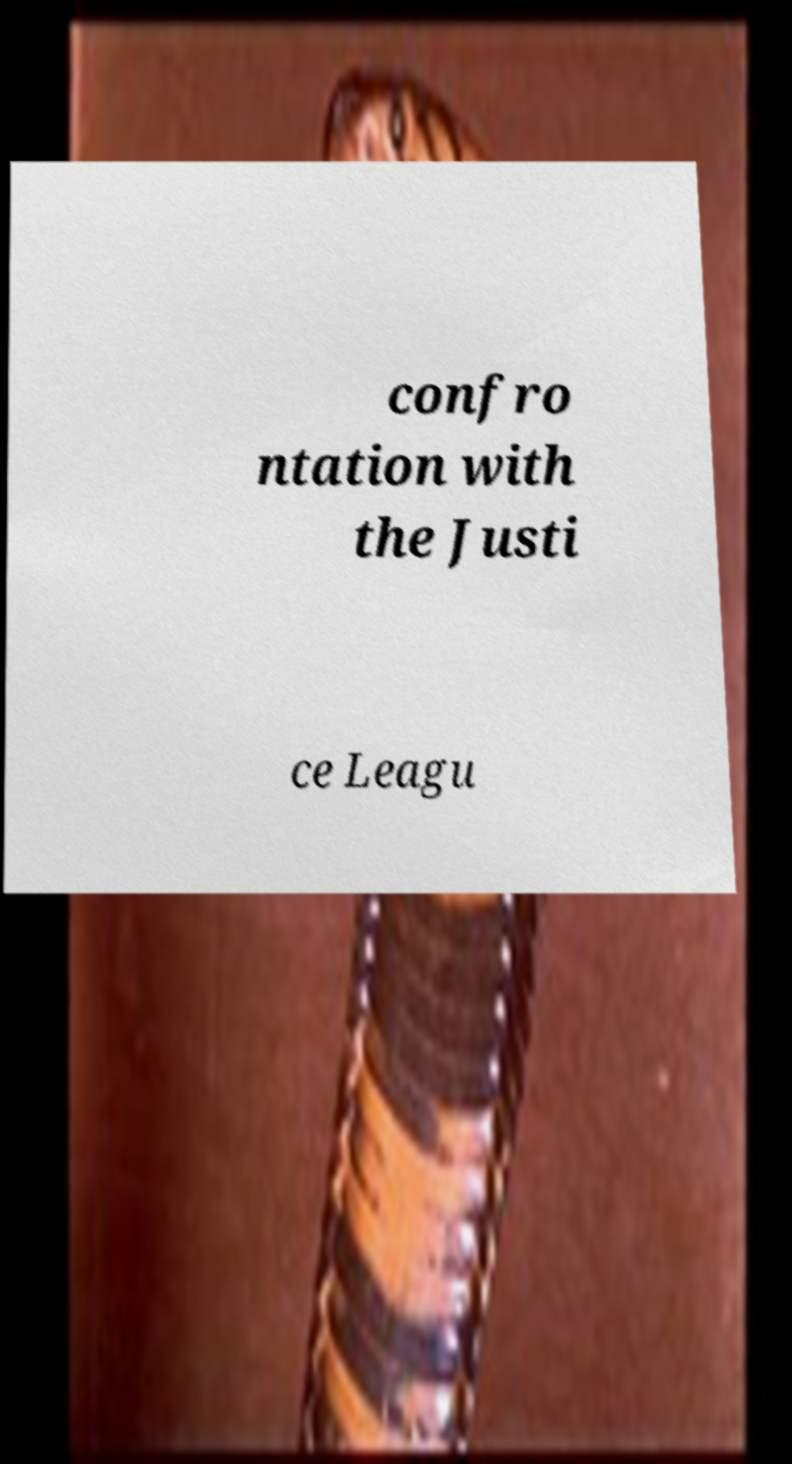Please read and relay the text visible in this image. What does it say? confro ntation with the Justi ce Leagu 